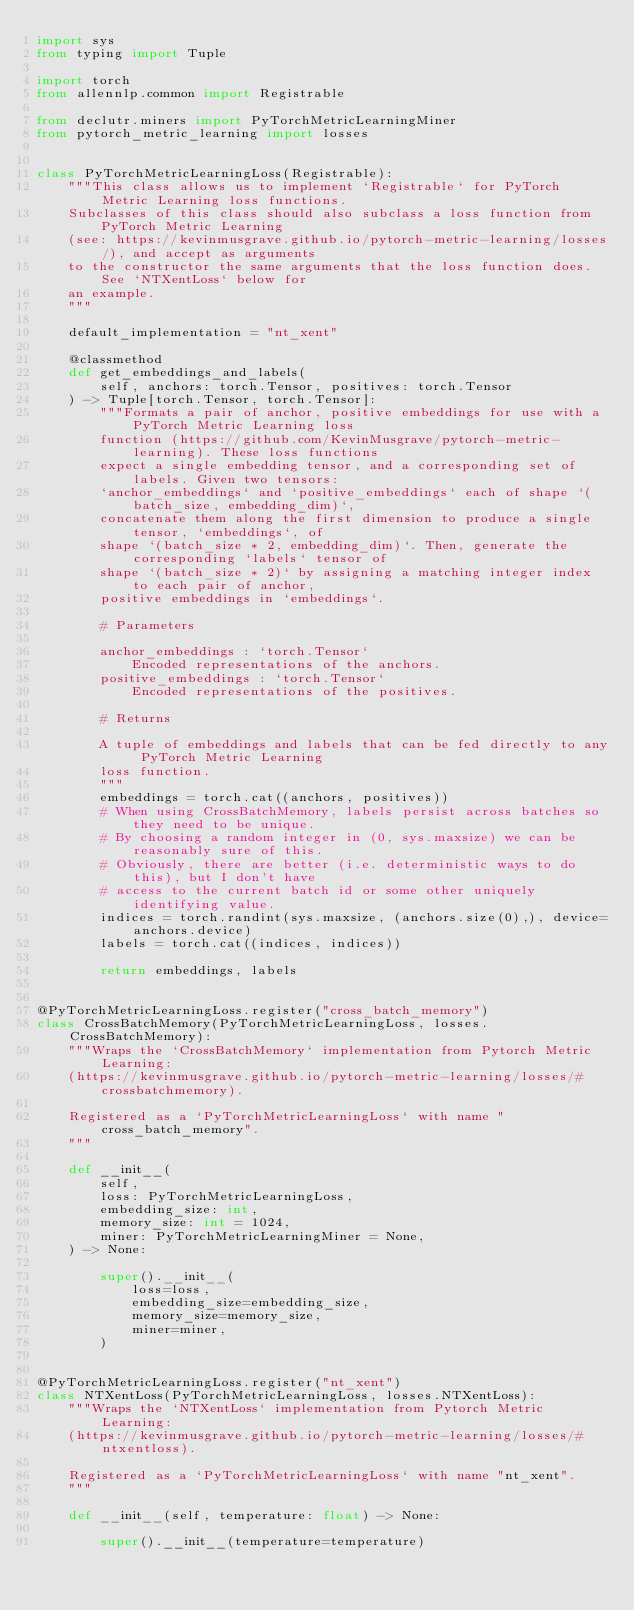Convert code to text. <code><loc_0><loc_0><loc_500><loc_500><_Python_>import sys
from typing import Tuple

import torch
from allennlp.common import Registrable

from declutr.miners import PyTorchMetricLearningMiner
from pytorch_metric_learning import losses


class PyTorchMetricLearningLoss(Registrable):
    """This class allows us to implement `Registrable` for PyTorch Metric Learning loss functions.
    Subclasses of this class should also subclass a loss function from PyTorch Metric Learning
    (see: https://kevinmusgrave.github.io/pytorch-metric-learning/losses/), and accept as arguments
    to the constructor the same arguments that the loss function does. See `NTXentLoss` below for
    an example.
    """

    default_implementation = "nt_xent"

    @classmethod
    def get_embeddings_and_labels(
        self, anchors: torch.Tensor, positives: torch.Tensor
    ) -> Tuple[torch.Tensor, torch.Tensor]:
        """Formats a pair of anchor, positive embeddings for use with a PyTorch Metric Learning loss
        function (https://github.com/KevinMusgrave/pytorch-metric-learning). These loss functions
        expect a single embedding tensor, and a corresponding set of labels. Given two tensors:
        `anchor_embeddings` and `positive_embeddings` each of shape `(batch_size, embedding_dim)`,
        concatenate them along the first dimension to produce a single tensor, `embeddings`, of
        shape `(batch_size * 2, embedding_dim)`. Then, generate the corresponding `labels` tensor of
        shape `(batch_size * 2)` by assigning a matching integer index to each pair of anchor,
        positive embeddings in `embeddings`.

        # Parameters

        anchor_embeddings : `torch.Tensor`
            Encoded representations of the anchors.
        positive_embeddings : `torch.Tensor`
            Encoded representations of the positives.

        # Returns

        A tuple of embeddings and labels that can be fed directly to any PyTorch Metric Learning
        loss function.
        """
        embeddings = torch.cat((anchors, positives))
        # When using CrossBatchMemory, labels persist across batches so they need to be unique.
        # By choosing a random integer in (0, sys.maxsize) we can be reasonably sure of this.
        # Obviously, there are better (i.e. deterministic ways to do this), but I don't have
        # access to the current batch id or some other uniquely identifying value.
        indices = torch.randint(sys.maxsize, (anchors.size(0),), device=anchors.device)
        labels = torch.cat((indices, indices))

        return embeddings, labels


@PyTorchMetricLearningLoss.register("cross_batch_memory")
class CrossBatchMemory(PyTorchMetricLearningLoss, losses.CrossBatchMemory):
    """Wraps the `CrossBatchMemory` implementation from Pytorch Metric Learning:
    (https://kevinmusgrave.github.io/pytorch-metric-learning/losses/#crossbatchmemory).

    Registered as a `PyTorchMetricLearningLoss` with name "cross_batch_memory".
    """

    def __init__(
        self,
        loss: PyTorchMetricLearningLoss,
        embedding_size: int,
        memory_size: int = 1024,
        miner: PyTorchMetricLearningMiner = None,
    ) -> None:

        super().__init__(
            loss=loss,
            embedding_size=embedding_size,
            memory_size=memory_size,
            miner=miner,
        )


@PyTorchMetricLearningLoss.register("nt_xent")
class NTXentLoss(PyTorchMetricLearningLoss, losses.NTXentLoss):
    """Wraps the `NTXentLoss` implementation from Pytorch Metric Learning:
    (https://kevinmusgrave.github.io/pytorch-metric-learning/losses/#ntxentloss).

    Registered as a `PyTorchMetricLearningLoss` with name "nt_xent".
    """

    def __init__(self, temperature: float) -> None:

        super().__init__(temperature=temperature)
</code> 